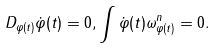<formula> <loc_0><loc_0><loc_500><loc_500>D _ { \varphi ( t ) } \dot { \varphi } ( t ) = 0 , \int \dot { \varphi } ( t ) \omega _ { \varphi ( t ) } ^ { n } = 0 .</formula> 